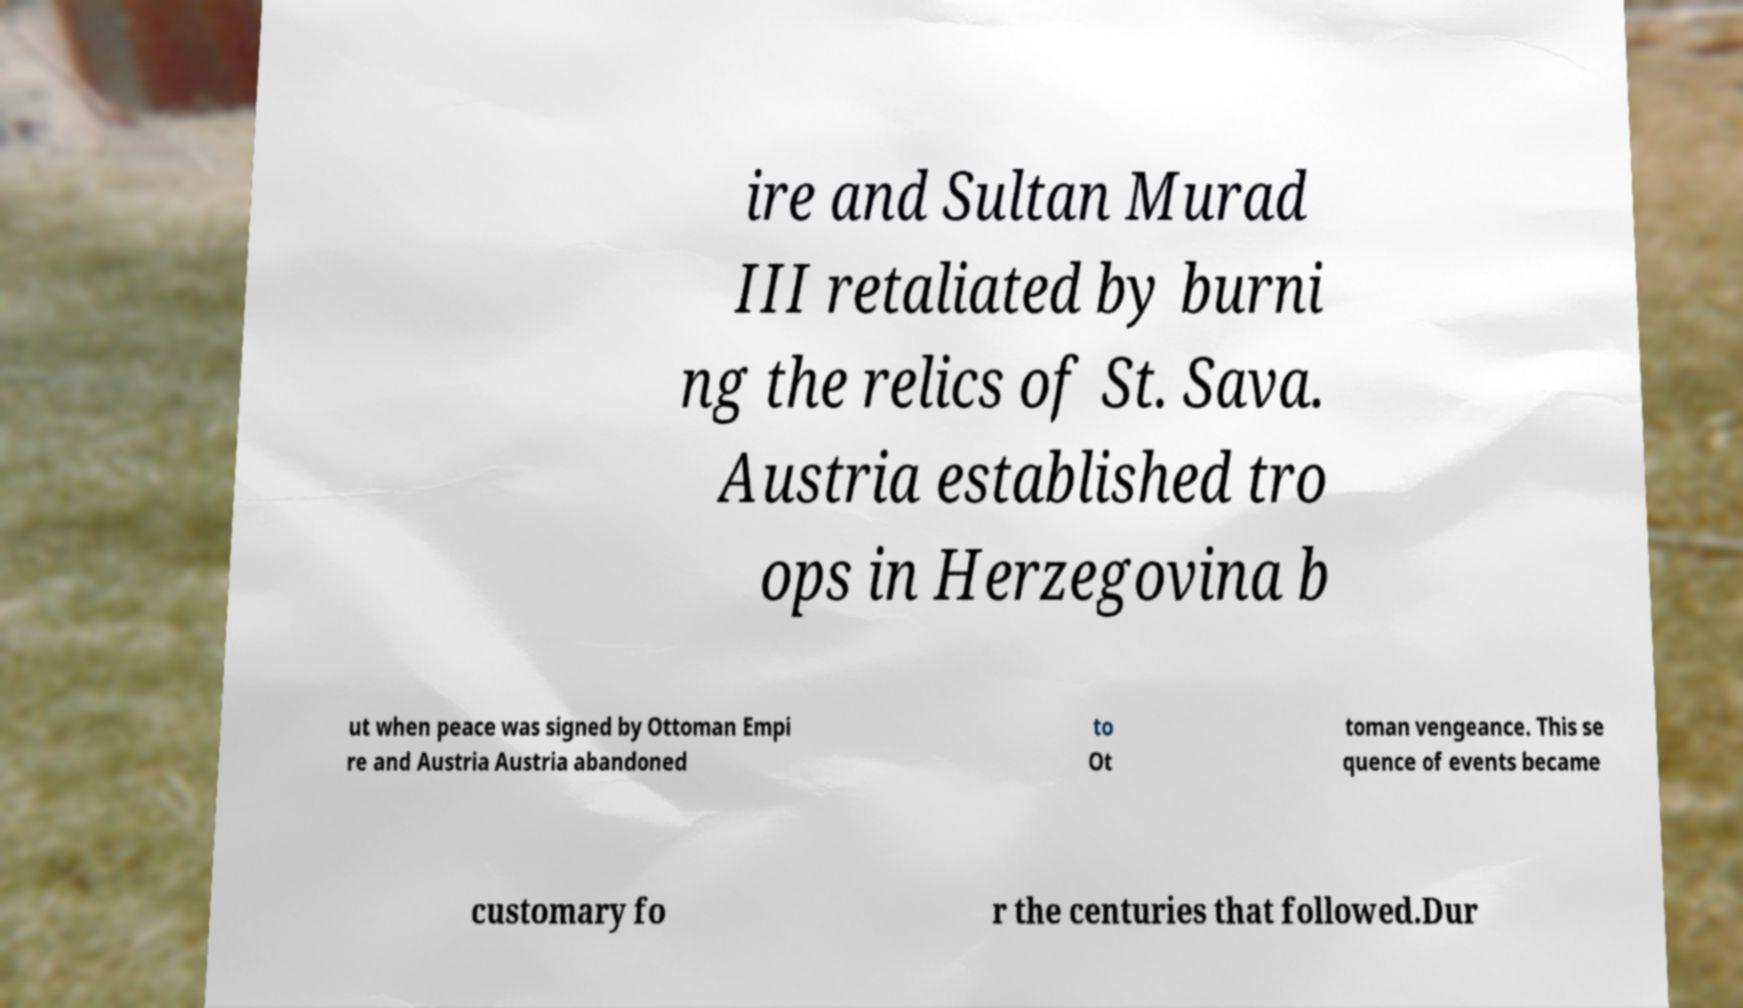What messages or text are displayed in this image? I need them in a readable, typed format. ire and Sultan Murad III retaliated by burni ng the relics of St. Sava. Austria established tro ops in Herzegovina b ut when peace was signed by Ottoman Empi re and Austria Austria abandoned to Ot toman vengeance. This se quence of events became customary fo r the centuries that followed.Dur 